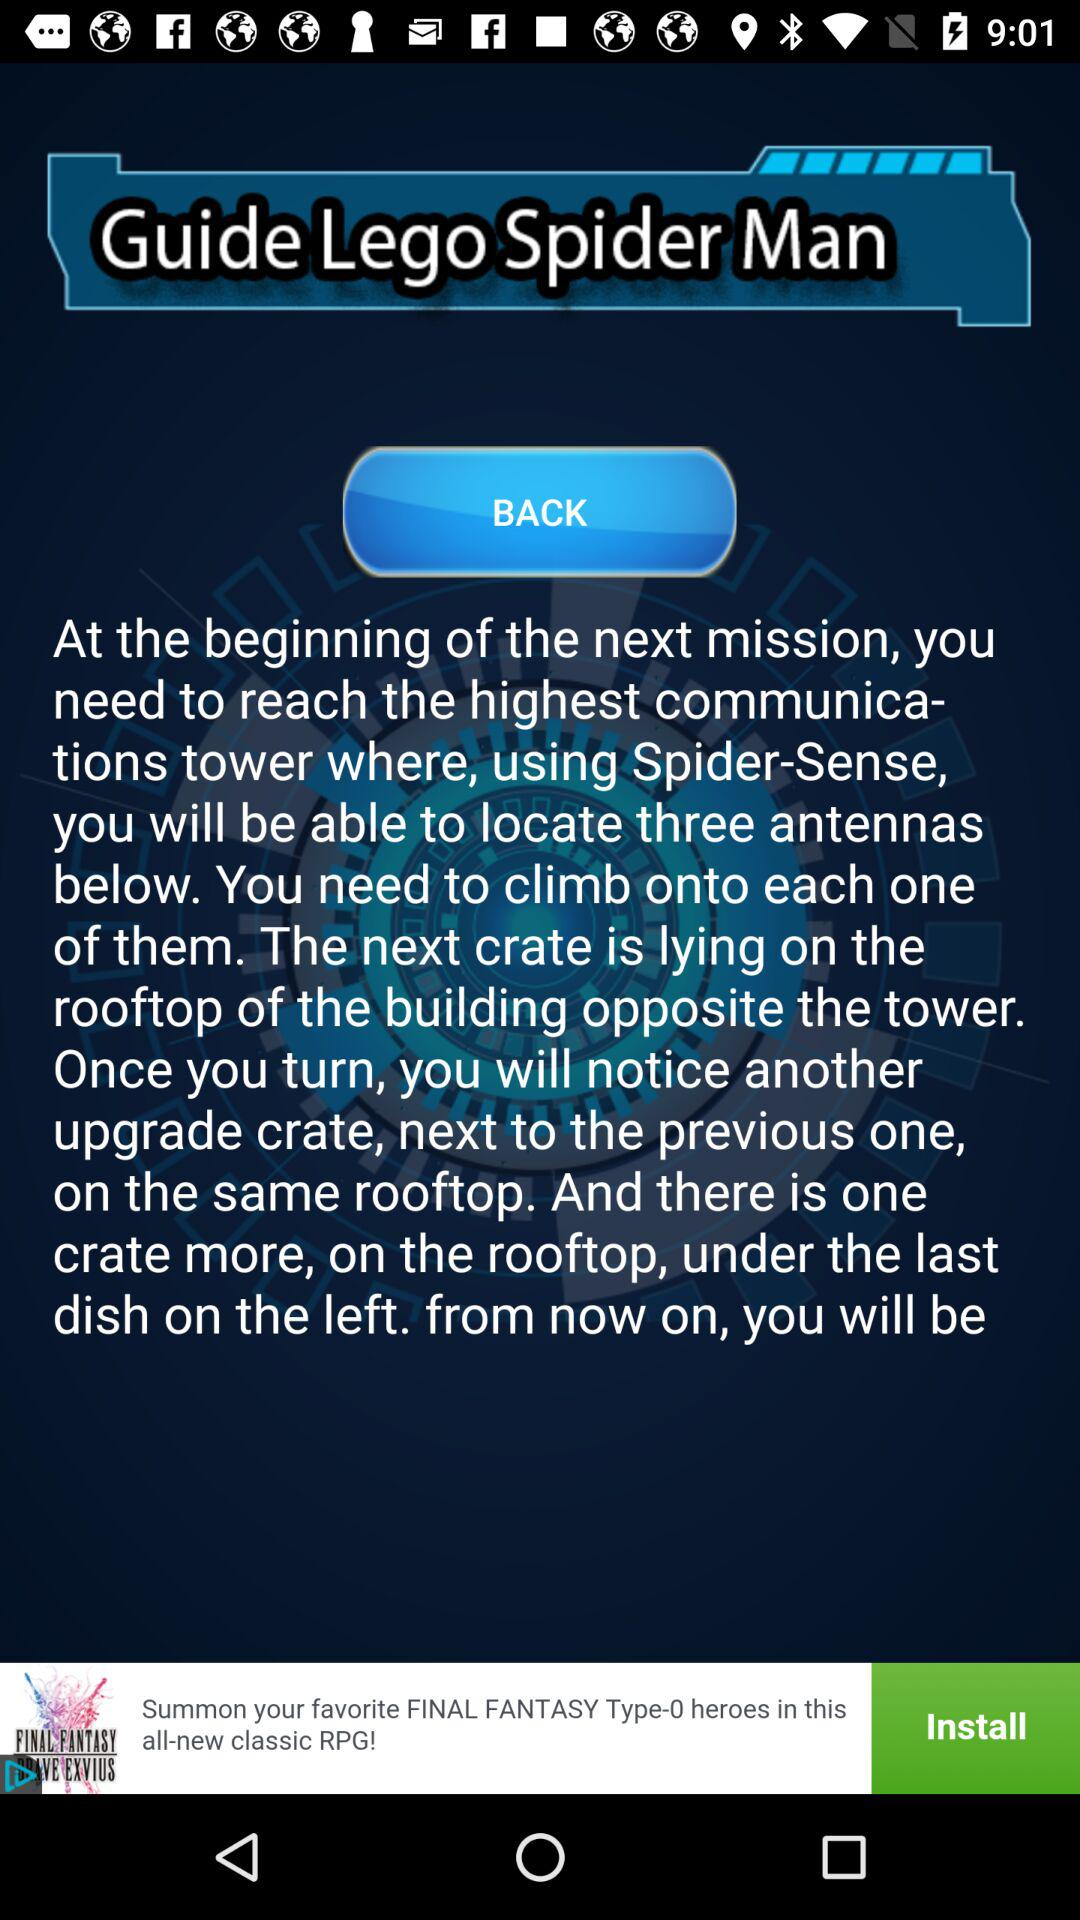What is the application name? The application name is "GuideLegoSpiderMan". 